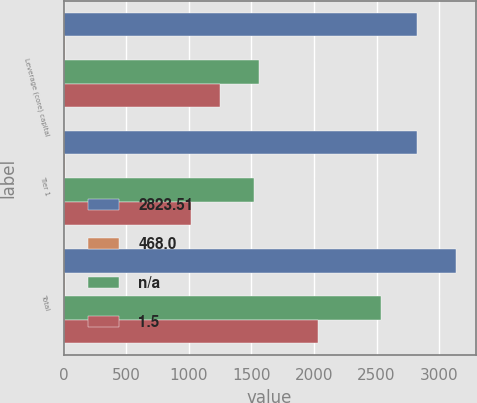<chart> <loc_0><loc_0><loc_500><loc_500><stacked_bar_chart><ecel><fcel>Leverage (core) capital<fcel>Tier 1<fcel>Total<nl><fcel>2823.51<fcel>2823.51<fcel>2823.51<fcel>3133.32<nl><fcel>468<fcel>9.1<fcel>11.1<fcel>12.4<nl><fcel>nan<fcel>1559.9<fcel>1521.4<fcel>2535.7<nl><fcel>1.5<fcel>1247.9<fcel>1014.3<fcel>2028.5<nl></chart> 